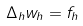<formula> <loc_0><loc_0><loc_500><loc_500>\Delta _ { h } w _ { h } = f _ { h }</formula> 